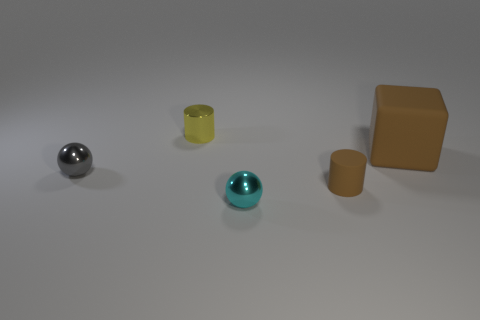There is a matte thing that is the same size as the gray metal ball; what is its color?
Offer a terse response. Brown. Do the cyan thing and the gray shiny thing have the same size?
Provide a short and direct response. Yes. What number of cylinders are behind the small rubber object?
Ensure brevity in your answer.  1. How many things are tiny objects in front of the big brown rubber cube or big yellow cylinders?
Your response must be concise. 3. Is the number of small yellow things in front of the brown cylinder greater than the number of cyan balls that are on the right side of the cyan ball?
Offer a terse response. No. What size is the rubber thing that is the same color as the large matte block?
Provide a succinct answer. Small. There is a rubber cylinder; is it the same size as the object that is behind the large thing?
Provide a short and direct response. Yes. How many spheres are large brown objects or tiny objects?
Make the answer very short. 2. What size is the object that is made of the same material as the cube?
Offer a terse response. Small. There is a brown cylinder that is to the right of the yellow metallic thing; is its size the same as the object that is behind the big brown block?
Provide a succinct answer. Yes. 